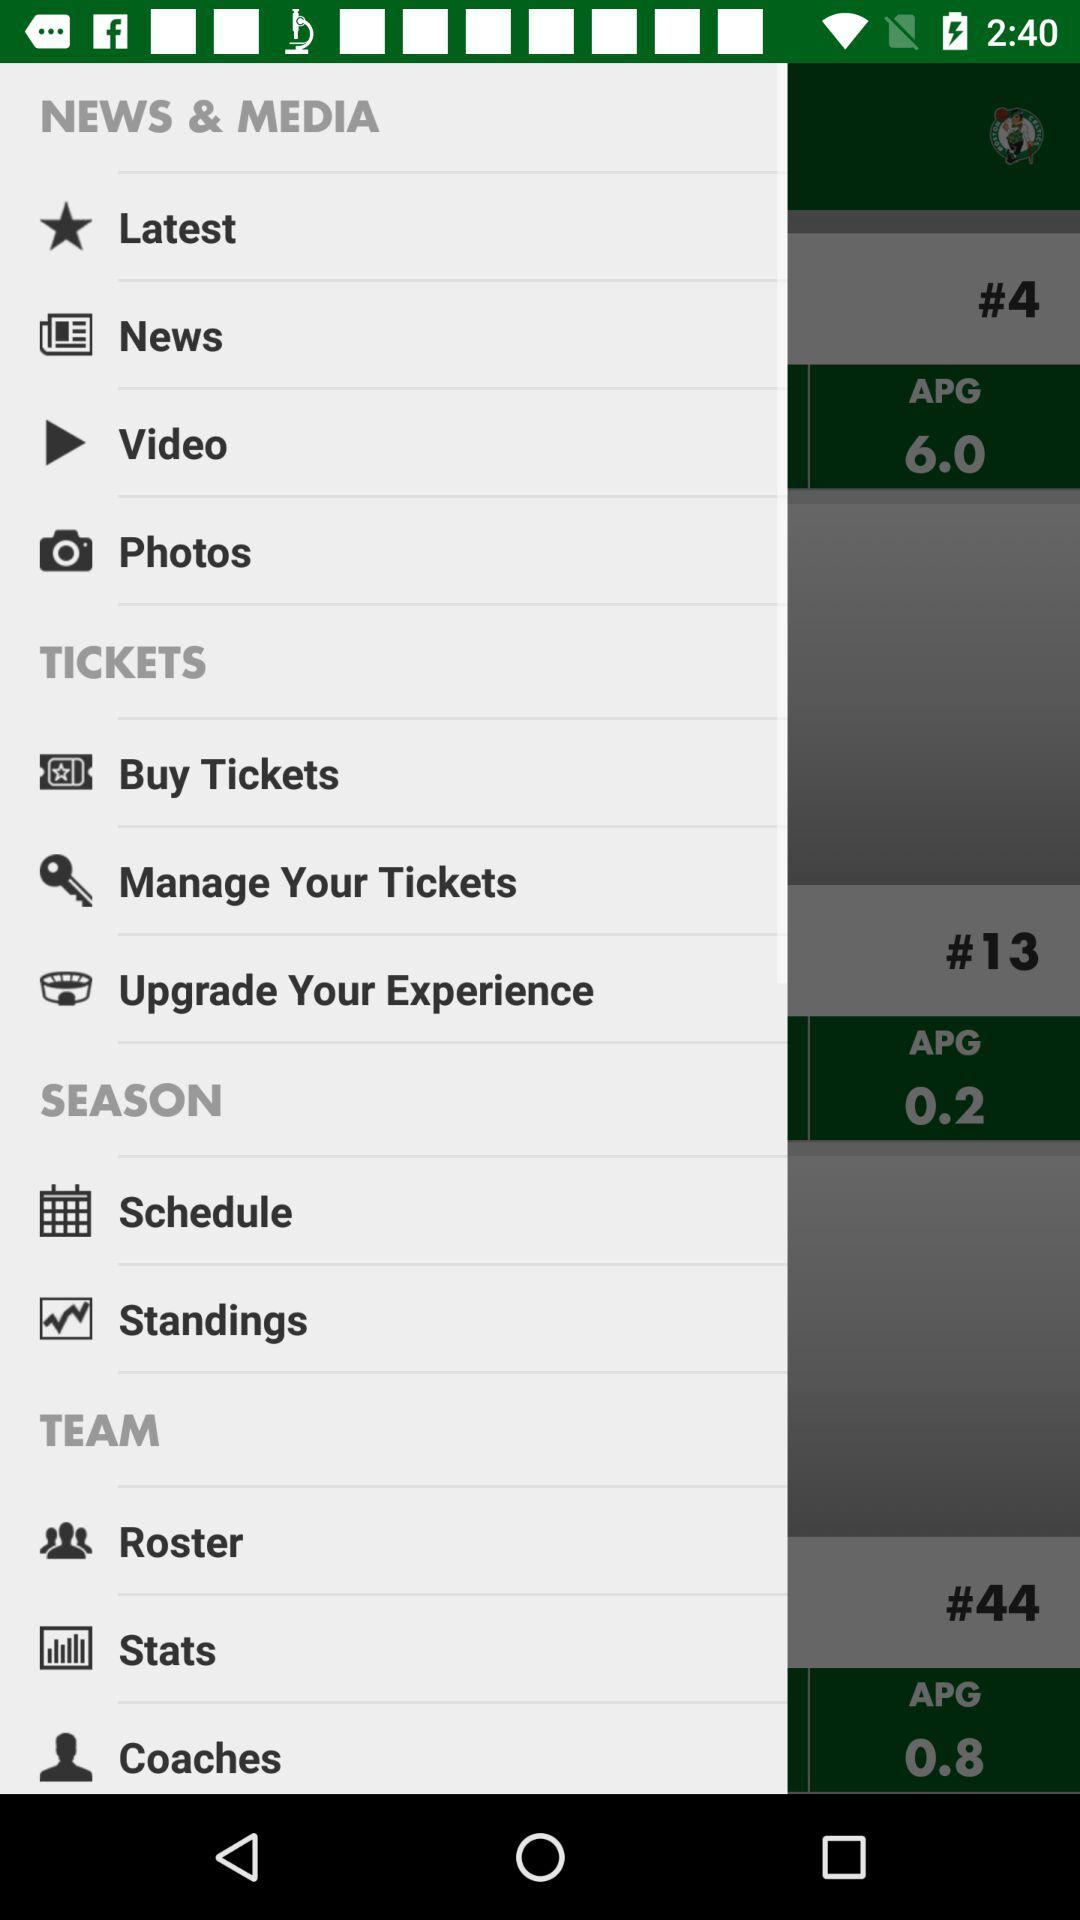How many items are in the 'News & Media' section?
Answer the question using a single word or phrase. 4 